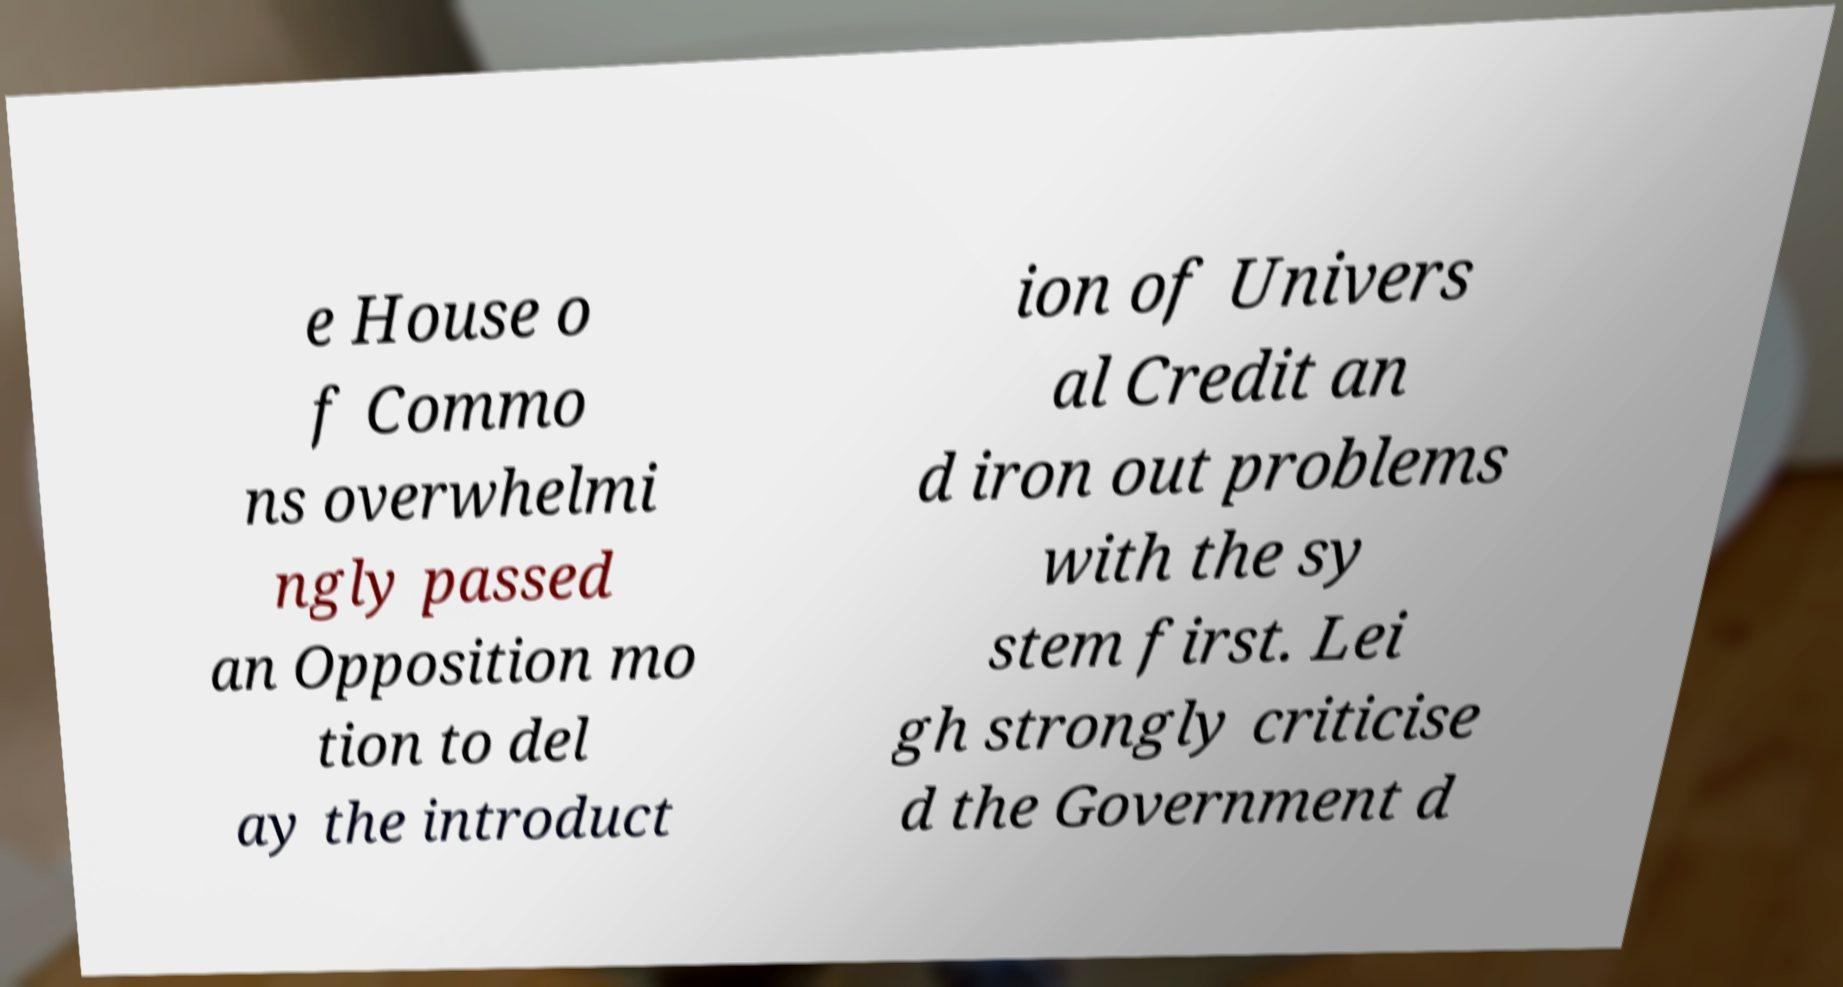For documentation purposes, I need the text within this image transcribed. Could you provide that? e House o f Commo ns overwhelmi ngly passed an Opposition mo tion to del ay the introduct ion of Univers al Credit an d iron out problems with the sy stem first. Lei gh strongly criticise d the Government d 